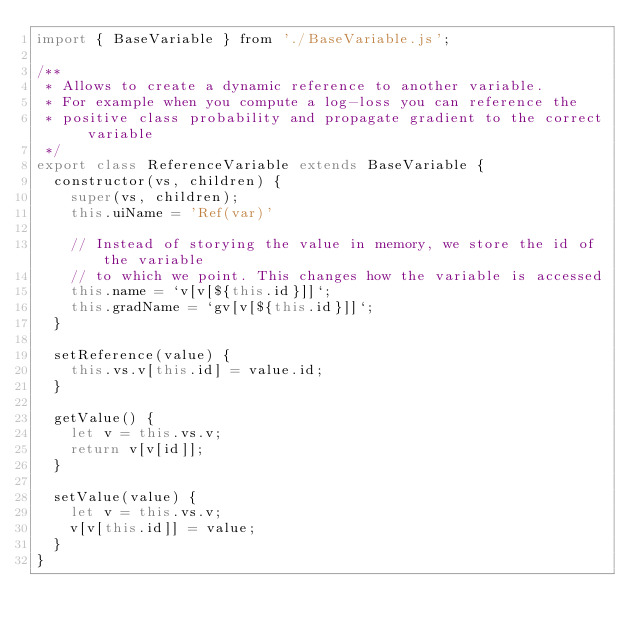Convert code to text. <code><loc_0><loc_0><loc_500><loc_500><_JavaScript_>import { BaseVariable } from './BaseVariable.js';

/**
 * Allows to create a dynamic reference to another variable.
 * For example when you compute a log-loss you can reference the
 * positive class probability and propagate gradient to the correct variable
 */
export class ReferenceVariable extends BaseVariable {
  constructor(vs, children) {
    super(vs, children);
    this.uiName = 'Ref(var)'

    // Instead of storying the value in memory, we store the id of the variable
    // to which we point. This changes how the variable is accessed
    this.name = `v[v[${this.id}]]`;
    this.gradName = `gv[v[${this.id}]]`;
  }

  setReference(value) {
    this.vs.v[this.id] = value.id;
  }

  getValue() {
    let v = this.vs.v;
    return v[v[id]];
  }

  setValue(value) {
    let v = this.vs.v;
    v[v[this.id]] = value;
  }
}</code> 